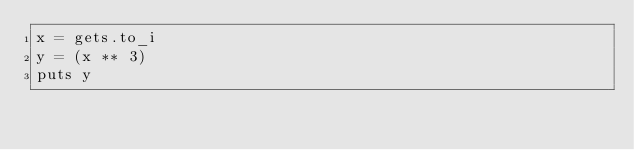Convert code to text. <code><loc_0><loc_0><loc_500><loc_500><_Ruby_>x = gets.to_i
y = (x ** 3)
puts y</code> 